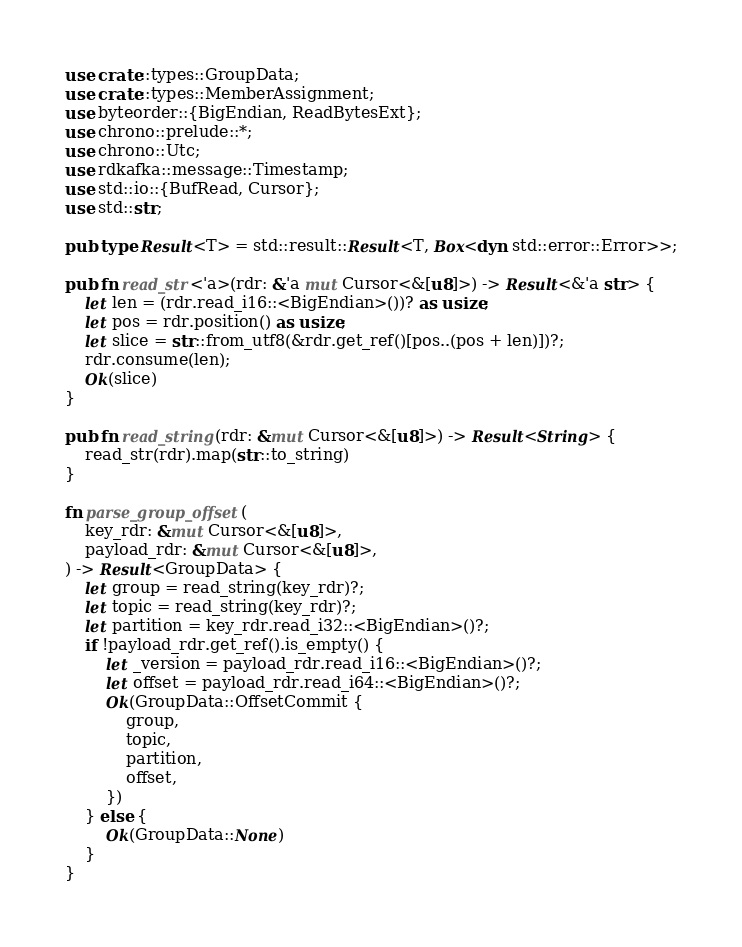Convert code to text. <code><loc_0><loc_0><loc_500><loc_500><_Rust_>use crate::types::GroupData;
use crate::types::MemberAssignment;
use byteorder::{BigEndian, ReadBytesExt};
use chrono::prelude::*;
use chrono::Utc;
use rdkafka::message::Timestamp;
use std::io::{BufRead, Cursor};
use std::str;

pub type Result<T> = std::result::Result<T, Box<dyn std::error::Error>>;

pub fn read_str<'a>(rdr: &'a mut Cursor<&[u8]>) -> Result<&'a str> {
    let len = (rdr.read_i16::<BigEndian>())? as usize;
    let pos = rdr.position() as usize;
    let slice = str::from_utf8(&rdr.get_ref()[pos..(pos + len)])?;
    rdr.consume(len);
    Ok(slice)
}

pub fn read_string(rdr: &mut Cursor<&[u8]>) -> Result<String> {
    read_str(rdr).map(str::to_string)
}

fn parse_group_offset(
    key_rdr: &mut Cursor<&[u8]>,
    payload_rdr: &mut Cursor<&[u8]>,
) -> Result<GroupData> {
    let group = read_string(key_rdr)?;
    let topic = read_string(key_rdr)?;
    let partition = key_rdr.read_i32::<BigEndian>()?;
    if !payload_rdr.get_ref().is_empty() {
        let _version = payload_rdr.read_i16::<BigEndian>()?;
        let offset = payload_rdr.read_i64::<BigEndian>()?;
        Ok(GroupData::OffsetCommit {
            group,
            topic,
            partition,
            offset,
        })
    } else {
        Ok(GroupData::None)
    }
}
</code> 